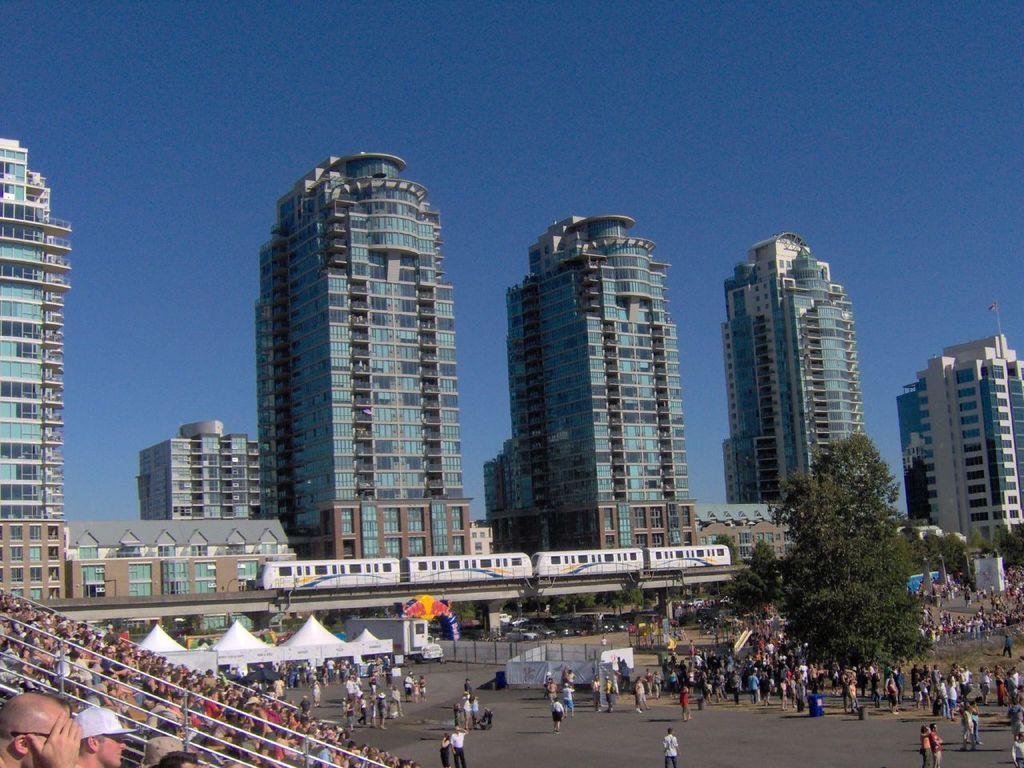Describe this image in one or two sentences. In this image we can see few buildings and the bridge, on the bridge we can see a train, there are some trees, poles, fence, tents, vehicles and people, in the background we can see the sky. 